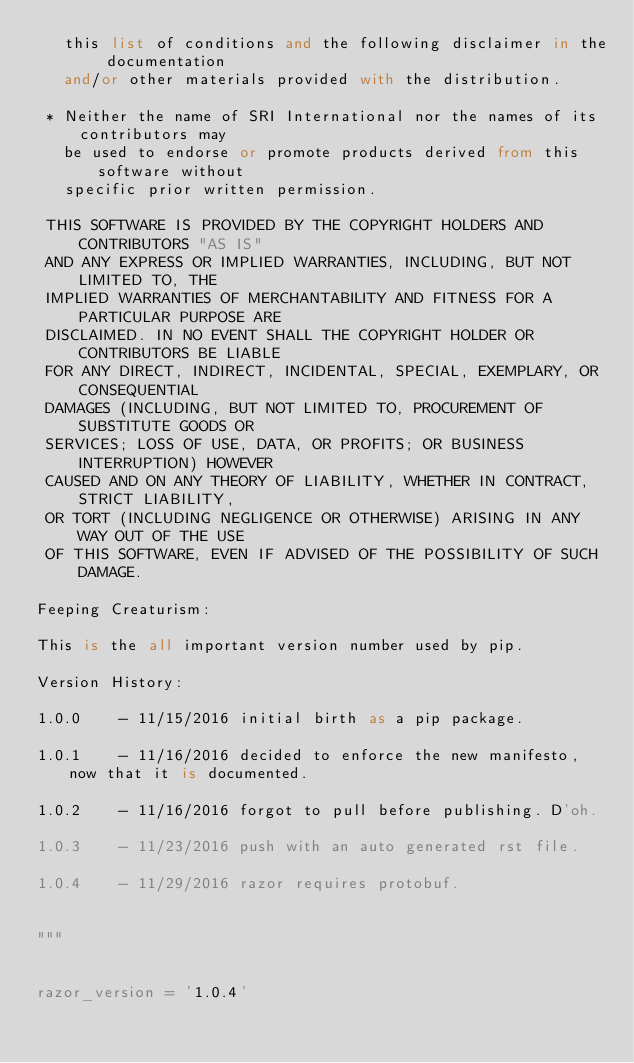Convert code to text. <code><loc_0><loc_0><loc_500><loc_500><_Python_>   this list of conditions and the following disclaimer in the documentation
   and/or other materials provided with the distribution.

 * Neither the name of SRI International nor the names of its contributors may
   be used to endorse or promote products derived from this software without
   specific prior written permission.

 THIS SOFTWARE IS PROVIDED BY THE COPYRIGHT HOLDERS AND CONTRIBUTORS "AS IS"
 AND ANY EXPRESS OR IMPLIED WARRANTIES, INCLUDING, BUT NOT LIMITED TO, THE
 IMPLIED WARRANTIES OF MERCHANTABILITY AND FITNESS FOR A PARTICULAR PURPOSE ARE
 DISCLAIMED. IN NO EVENT SHALL THE COPYRIGHT HOLDER OR CONTRIBUTORS BE LIABLE
 FOR ANY DIRECT, INDIRECT, INCIDENTAL, SPECIAL, EXEMPLARY, OR CONSEQUENTIAL
 DAMAGES (INCLUDING, BUT NOT LIMITED TO, PROCUREMENT OF SUBSTITUTE GOODS OR
 SERVICES; LOSS OF USE, DATA, OR PROFITS; OR BUSINESS INTERRUPTION) HOWEVER
 CAUSED AND ON ANY THEORY OF LIABILITY, WHETHER IN CONTRACT, STRICT LIABILITY,
 OR TORT (INCLUDING NEGLIGENCE OR OTHERWISE) ARISING IN ANY WAY OUT OF THE USE
 OF THIS SOFTWARE, EVEN IF ADVISED OF THE POSSIBILITY OF SUCH DAMAGE.

Feeping Creaturism:

This is the all important version number used by pip.

Version History:

1.0.0    - 11/15/2016 initial birth as a pip package.

1.0.1    - 11/16/2016 decided to enforce the new manifesto, now that it is documented.

1.0.2    - 11/16/2016 forgot to pull before publishing. D'oh.

1.0.3    - 11/23/2016 push with an auto generated rst file.

1.0.4    - 11/29/2016 razor requires protobuf.


"""


razor_version = '1.0.4'
</code> 